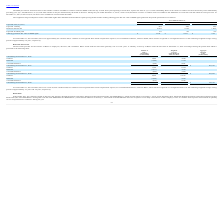According to Ringcentral's financial document, How many years do the RSUs issued under the 2013 Plan generally vest over? According to the financial document, four years. The relevant text states: "Us issued under the 2013 Plan generally vest over four years. A summary of activity of RSUs under the 2013 Plan at December 31, 2019 and changes during the peri..." Also, As of December 31 2019 and 2018, what are the respective values of unrecognized share-based compensation expense, net of estimated forfeitures, related to RSUs? The document shows two values: $198.3 million and $107.9 million. From the document: "and 2018, there was a total of $198.3 million and $107.9 million of unrecognized share-based compensation expense, net of estimated forfeitures, relat..." Also, As of December 31, 2019 and 2018, what are the respective remaining weighted-average vesting periods of  unrecognized share-based compensation expense, net of estimated forfeitures, related to RSUs? The document shows two values: 2.3 years and 2.4 years. From the document: "periods of approximately 2.3 years and 2.4 years, respectively. periods of approximately 2.3 years and 2.4 years, respectively...." Also, can you calculate: What is the percentage change in outstanding RSUs between December 31, 2016 and December 31, 2017? To answer this question, I need to perform calculations using the financial data. The calculation is: (4,281 - 3,554)/3,554 , which equals 20.46 (percentage). This is based on the information: "Outstanding at December 31, 2017 4,281 $ 25.51 $ 207,197 Outstanding at December 31, 2016 3,554 $ 18.01 $ 73,261..." The key data points involved are: 3,554, 4,281. Also, can you calculate: What is the percentage change in outstanding RSUs between December 31, 2017 and December 31, 2018? To answer this question, I need to perform calculations using the financial data. The calculation is: (3,561 - 4,281)/4,281 , which equals -16.82 (percentage). This is based on the information: "Outstanding at December 31, 2017 4,281 $ 25.51 $ 207,197 Outstanding at December 31, 2018 3,561 $ 42.09 $ 293,523..." The key data points involved are: 3,561, 4,281. Also, can you calculate: What is the percentage of granted RSUs as a percentage of outstanding RSUs at December 2016? Based on the calculation: (3,005/3,554) , the result is 84.55 (percentage). This is based on the information: "Granted 3,005 30.20 Outstanding at December 31, 2016 3,554 $ 18.01 $ 73,261..." The key data points involved are: 3,005, 3,554. 